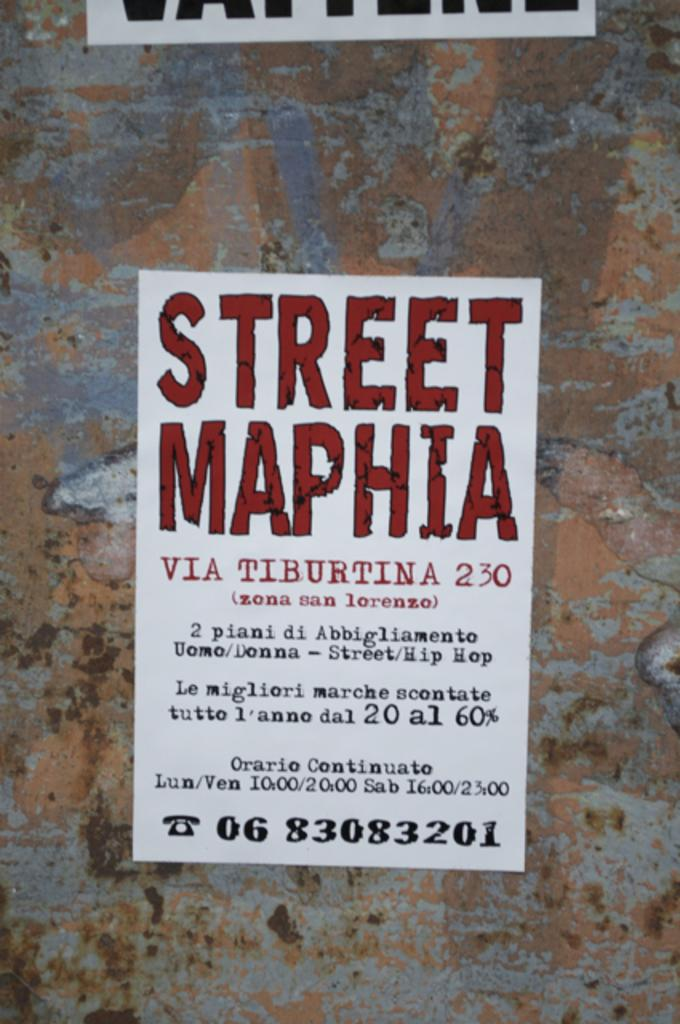Provide a one-sentence caption for the provided image. A poster for "Street Maphia" is hanging on a stone wall. 